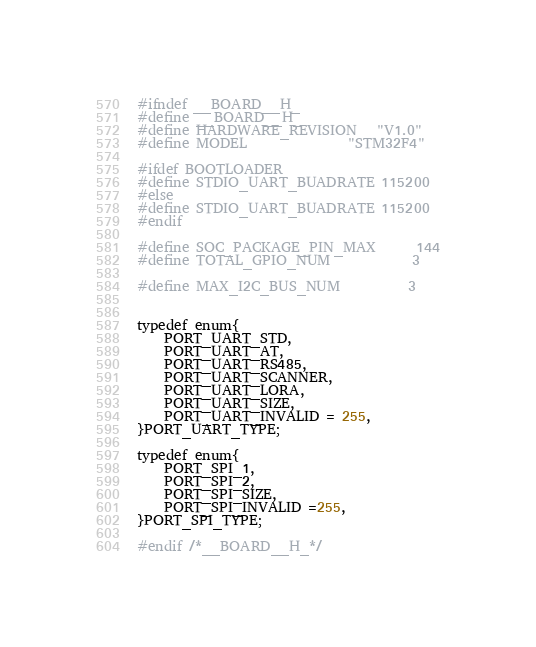Convert code to text. <code><loc_0><loc_0><loc_500><loc_500><_C_>#ifndef __BOARD__H_
#define __BOARD__H_
#define HARDWARE_REVISION   "V1.0"
#define MODEL               "STM32F4"

#ifdef BOOTLOADER
#define STDIO_UART_BUADRATE 115200
#else
#define STDIO_UART_BUADRATE 115200
#endif

#define SOC_PACKAGE_PIN_MAX      144
#define TOTAL_GPIO_NUM            3

#define MAX_I2C_BUS_NUM          3


typedef enum{
    PORT_UART_STD,
    PORT_UART_AT,
    PORT_UART_RS485,
    PORT_UART_SCANNER,
    PORT_UART_LORA,
    PORT_UART_SIZE,
    PORT_UART_INVALID = 255,
}PORT_UART_TYPE;

typedef enum{
    PORT_SPI_1,
    PORT_SPI_2,
    PORT_SPI_SIZE,
    PORT_SPI_INVALID =255,
}PORT_SPI_TYPE;

#endif /*__BOARD__H_*/

</code> 